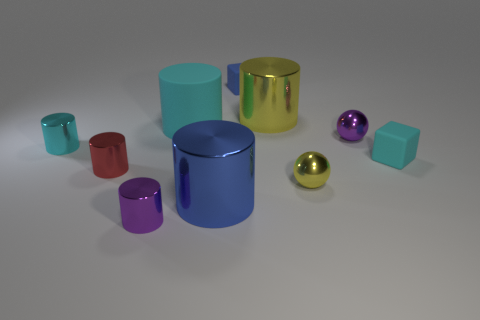Subtract 2 cylinders. How many cylinders are left? 4 Subtract all blue cylinders. How many cylinders are left? 5 Subtract all large cyan cylinders. How many cylinders are left? 5 Subtract all blue cylinders. Subtract all cyan cubes. How many cylinders are left? 5 Subtract all cubes. How many objects are left? 8 Add 1 tiny purple metallic objects. How many tiny purple metallic objects exist? 3 Subtract 1 red cylinders. How many objects are left? 9 Subtract all blue metal cylinders. Subtract all yellow metal cylinders. How many objects are left? 8 Add 1 blue shiny cylinders. How many blue shiny cylinders are left? 2 